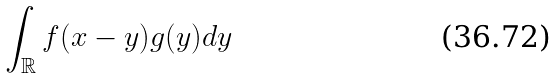<formula> <loc_0><loc_0><loc_500><loc_500>\int _ { \mathbb { R } } f ( x - y ) g ( y ) d y</formula> 